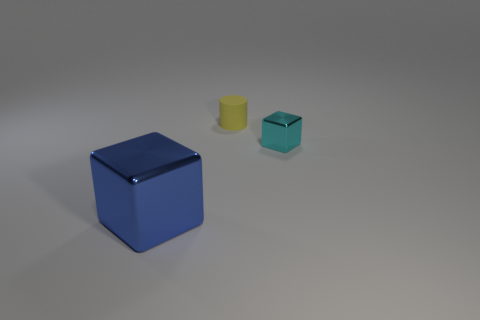Add 1 tiny gray matte cylinders. How many objects exist? 4 Subtract all cylinders. How many objects are left? 2 Add 3 tiny matte cylinders. How many tiny matte cylinders exist? 4 Subtract 0 red blocks. How many objects are left? 3 Subtract all blue rubber cylinders. Subtract all cyan things. How many objects are left? 2 Add 1 cyan objects. How many cyan objects are left? 2 